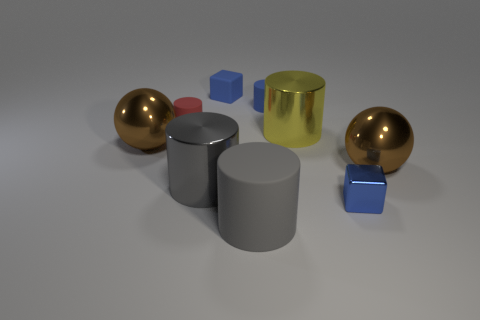Subtract all red cylinders. How many cylinders are left? 4 Subtract 2 cylinders. How many cylinders are left? 3 Subtract all small blue rubber cylinders. How many cylinders are left? 4 Subtract all red cylinders. Subtract all brown spheres. How many cylinders are left? 4 Add 1 small blue metallic objects. How many objects exist? 10 Subtract all cylinders. How many objects are left? 4 Subtract all red matte things. Subtract all blue metal objects. How many objects are left? 7 Add 3 tiny cylinders. How many tiny cylinders are left? 5 Add 4 metallic cylinders. How many metallic cylinders exist? 6 Subtract 0 yellow blocks. How many objects are left? 9 